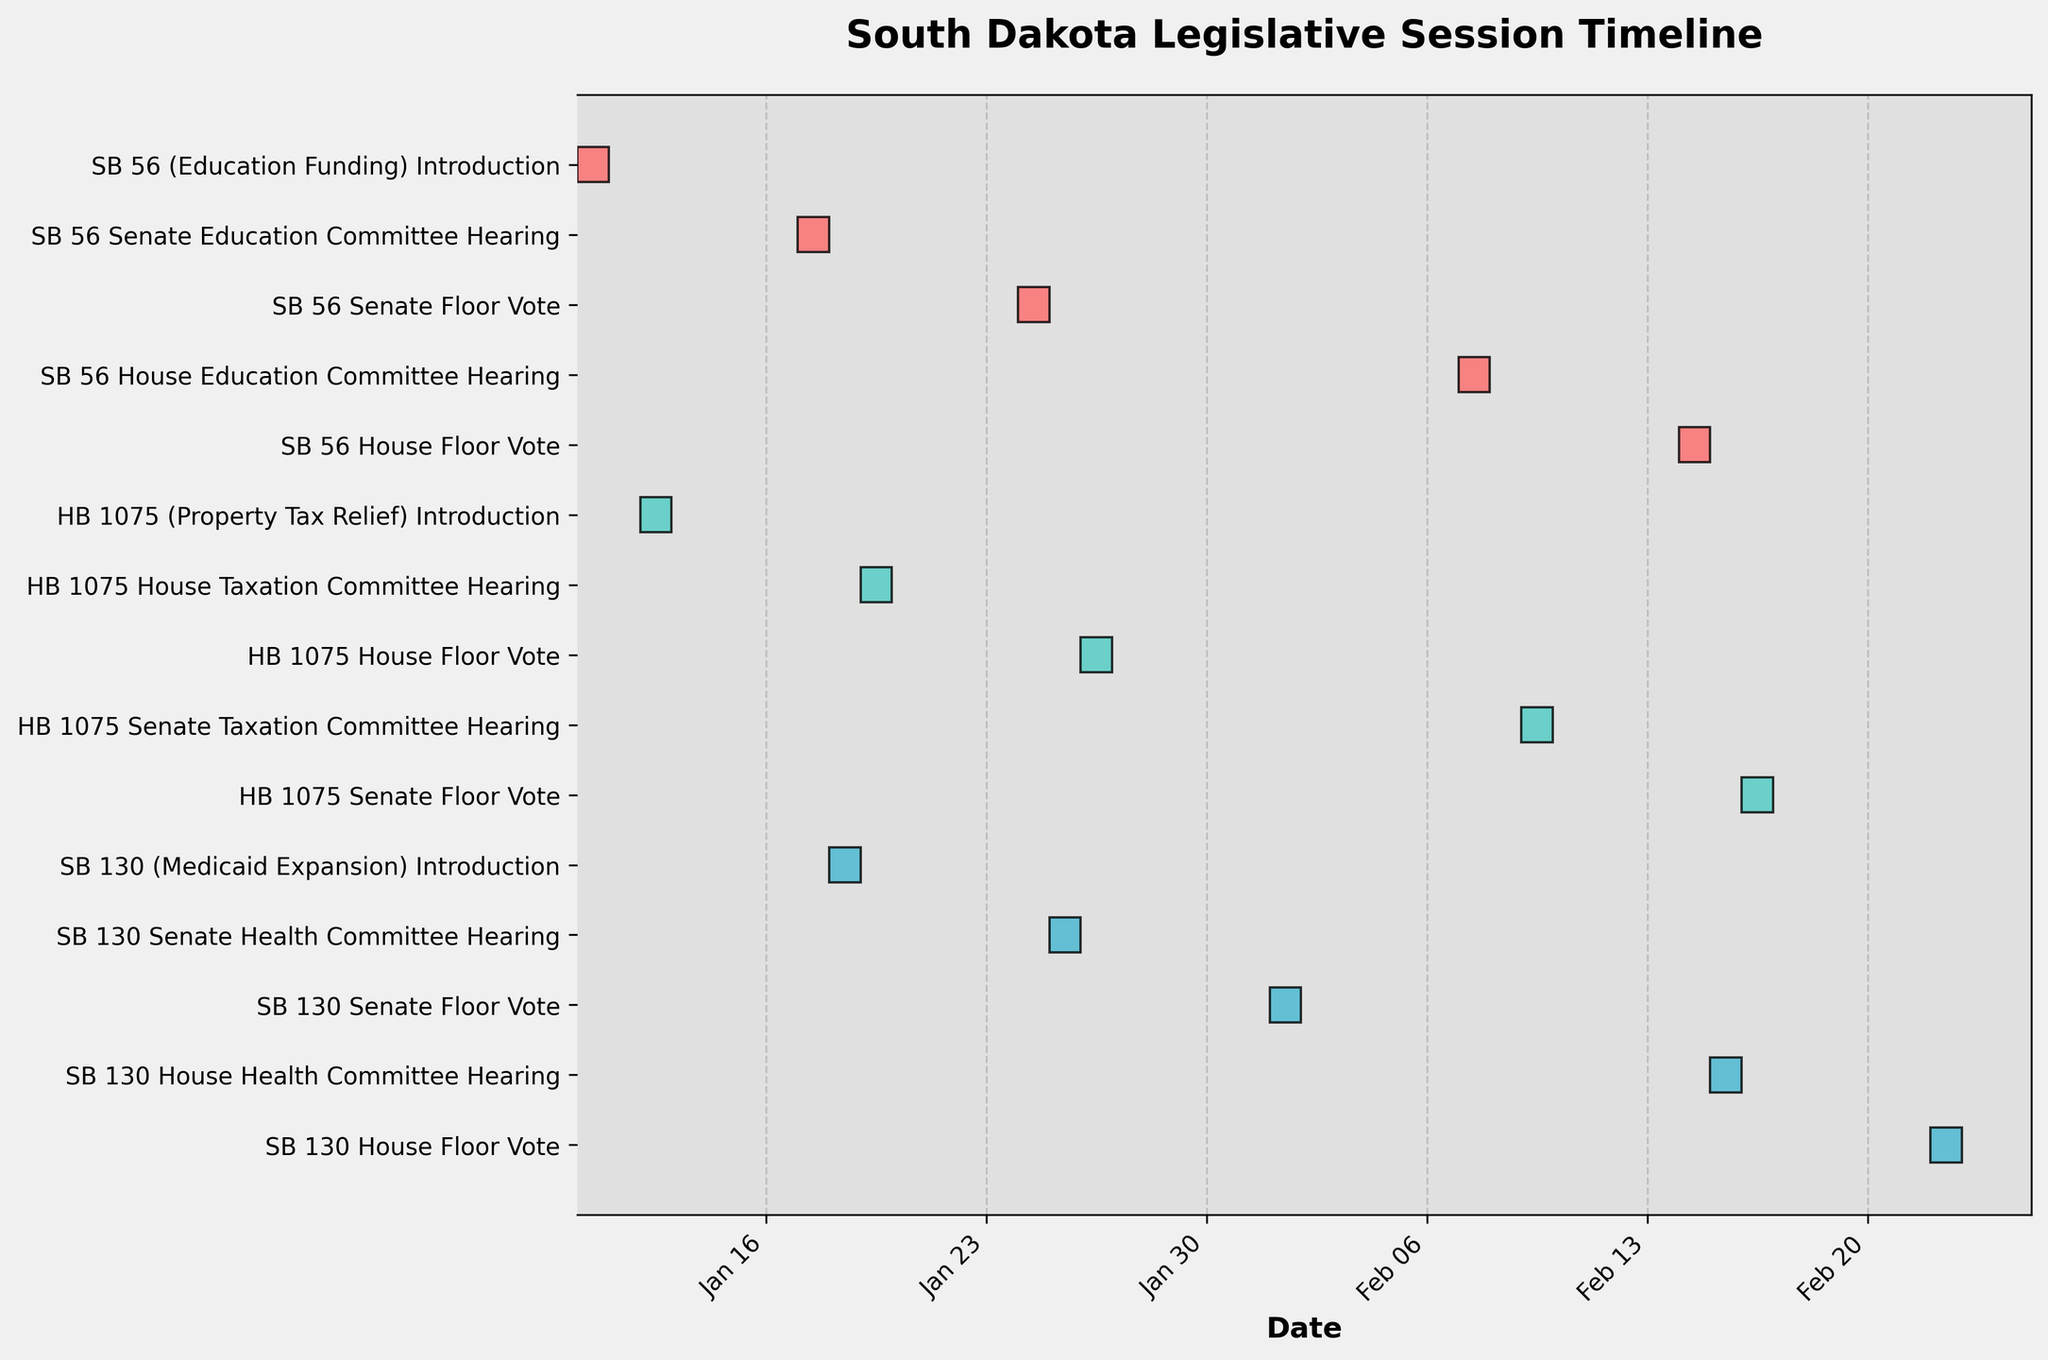What's the title of the Gantt Chart? The title is indicated at the top of the chart and typically summarizes the main focus of the Gantt Chart.
Answer: South Dakota Legislative Session Timeline Which bill has its Senate Floor Vote first, SB 56 or SB 130? By comparing the dates of the Senate Floor Votes for SB 56 and SB 130 on the Gantt Chart, we can see which occurred earlier. SB 56's vote is on January 24, while SB 130’s vote is on February 1.
Answer: SB 56 How many days are there between the introduction of HB 1075 and its House Taxation Committee Hearing? The Gantt Chart shows the introduction of HB 1075 on January 12 and the House Taxation Committee Hearing on January 19. By calculating the difference between these dates, we get 7 days.
Answer: 7 days What's the total number of committee hearings for all bills combined? By counting all the instances labeled as committee hearings on the Gantt Chart, we find there are 6 committee hearings in total.
Answer: 6 How does the duration from the Senate Committee Hearing to the House Floor Vote of SB 56 compare to SB 130? For SB 56, the Senate Committee Hearing is on January 17 and the House Floor Vote is on February 14. For SB 130, the Senate Committee Hearing is on January 25 and the House Floor Vote is on February 22. Calculating the number of days between these dates gives us 28 days for SB 56 and 28 days for SB 130. Therefore, both durations are the same.
Answer: They are the same On which exact date does the House Floor Vote for HB 1075 occur? By referring to the House Floor Vote for HB 1075 in the Gantt Chart, we find it occurs on January 26.
Answer: January 26 What is the color used to represent SB 56 tasks in the chart? The tasks for each bill appear in different colors. The color used for SB 56 tasks is the first distinct color shown on the chart.
Answer: Red How much time passed between the introduction of SB 130 and its House Health Committee Hearing? The introduction of SB 130 is on January 18 and its House Health Committee Hearing is on February 15. By calculating the difference between these dates, 28 days have passed.
Answer: 28 days Which committee had the hearing for HB 1075 before the Senate Taxation Committee? Referring to the sequence of committee hearings for HB 1075 on the Gantt Chart, the House Taxation Committee hearing occurs before the Senate Taxation Committee hearing.
Answer: House Taxation Committee What are the dates for the House Education Committee Hearing and the House Floor Vote for SB 56? By looking up these specific events in the Gantt Chart, the House Education Committee Hearing is on February 7 and the House Floor Vote is on February 14.
Answer: February 7, February 14 